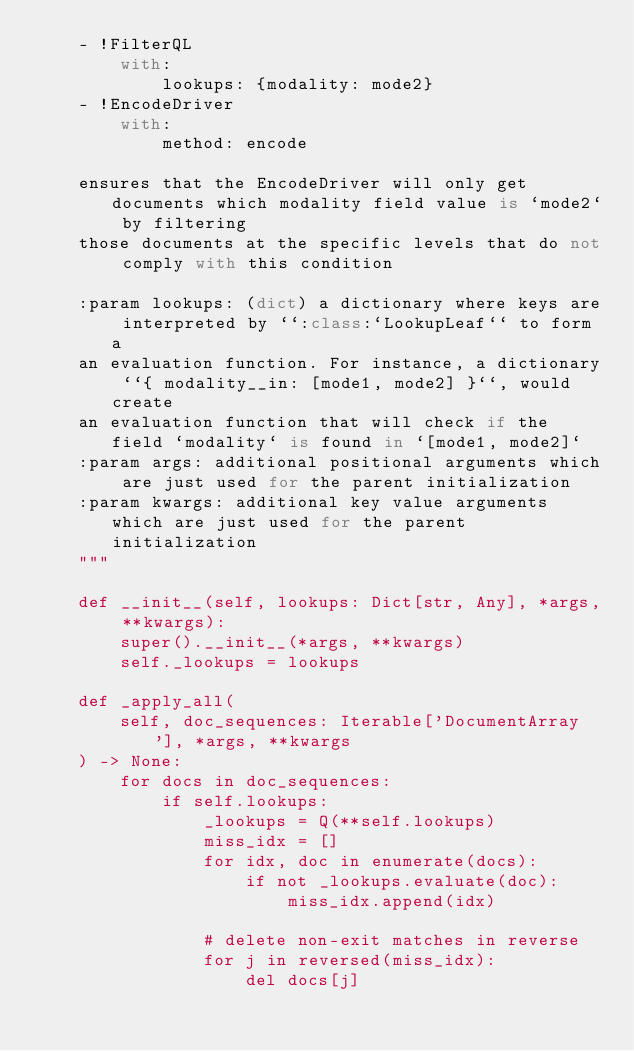Convert code to text. <code><loc_0><loc_0><loc_500><loc_500><_Python_>    - !FilterQL
        with:
            lookups: {modality: mode2}
    - !EncodeDriver
        with:
            method: encode

    ensures that the EncodeDriver will only get documents which modality field value is `mode2` by filtering
    those documents at the specific levels that do not comply with this condition

    :param lookups: (dict) a dictionary where keys are interpreted by ``:class:`LookupLeaf`` to form a
    an evaluation function. For instance, a dictionary ``{ modality__in: [mode1, mode2] }``, would create
    an evaluation function that will check if the field `modality` is found in `[mode1, mode2]`
    :param args: additional positional arguments which are just used for the parent initialization
    :param kwargs: additional key value arguments which are just used for the parent initialization
    """

    def __init__(self, lookups: Dict[str, Any], *args, **kwargs):
        super().__init__(*args, **kwargs)
        self._lookups = lookups

    def _apply_all(
        self, doc_sequences: Iterable['DocumentArray'], *args, **kwargs
    ) -> None:
        for docs in doc_sequences:
            if self.lookups:
                _lookups = Q(**self.lookups)
                miss_idx = []
                for idx, doc in enumerate(docs):
                    if not _lookups.evaluate(doc):
                        miss_idx.append(idx)

                # delete non-exit matches in reverse
                for j in reversed(miss_idx):
                    del docs[j]
</code> 